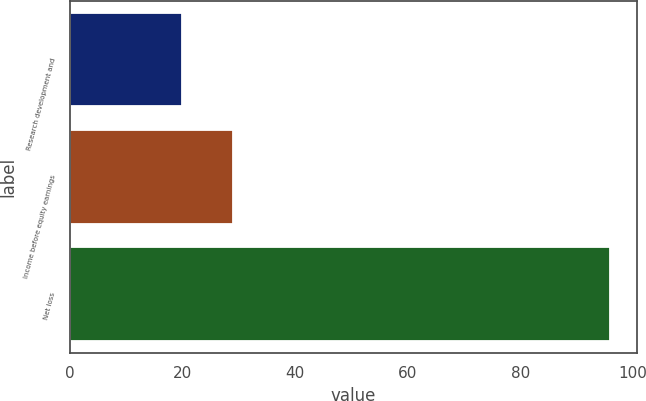Convert chart. <chart><loc_0><loc_0><loc_500><loc_500><bar_chart><fcel>Research development and<fcel>Income before equity earnings<fcel>Net loss<nl><fcel>20<fcel>29<fcel>96<nl></chart> 